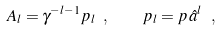Convert formula to latex. <formula><loc_0><loc_0><loc_500><loc_500>A _ { l } = \gamma ^ { - l - 1 } p _ { l } \ , \quad p _ { l } = p \, \hat { a } ^ { l } \ ,</formula> 